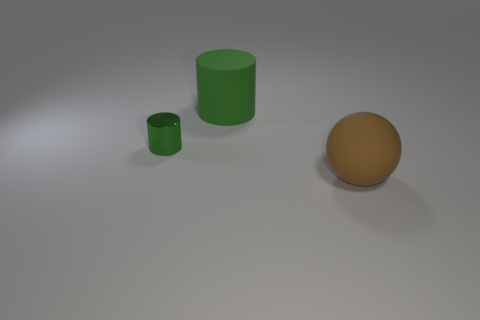Add 1 tiny brown rubber cubes. How many objects exist? 4 Subtract 1 cylinders. How many cylinders are left? 1 Subtract all cylinders. How many objects are left? 1 Subtract all red cylinders. Subtract all purple cubes. How many cylinders are left? 2 Subtract all big green cylinders. Subtract all large matte spheres. How many objects are left? 1 Add 2 metallic things. How many metallic things are left? 3 Add 2 purple metal cylinders. How many purple metal cylinders exist? 2 Subtract 0 yellow balls. How many objects are left? 3 